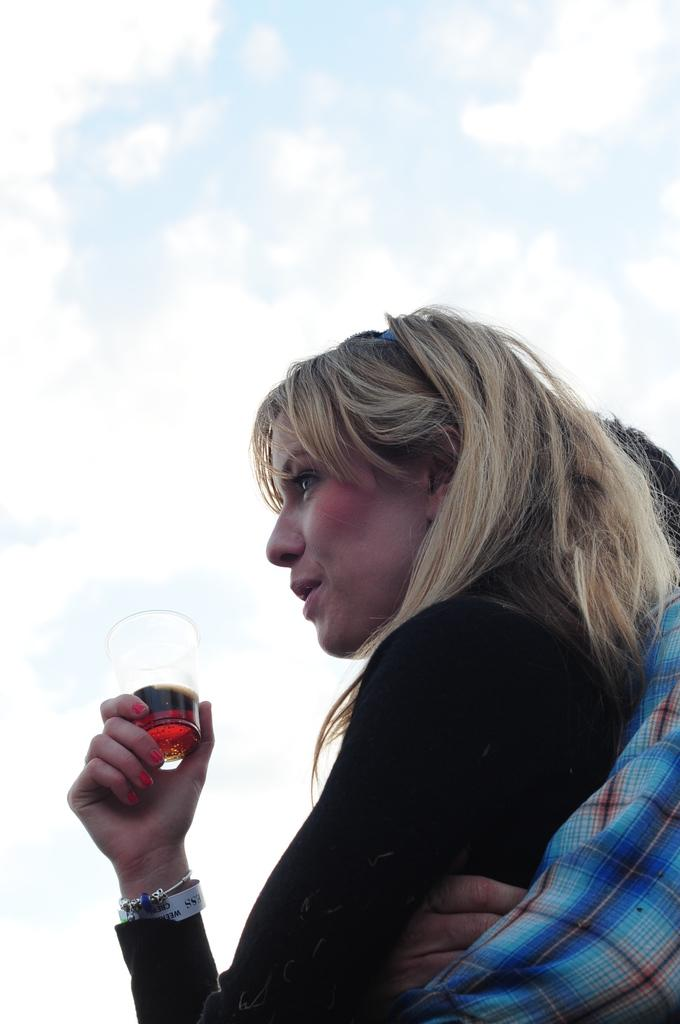Who are the people in the image? There is a man and a woman in the image. What is the woman holding in the image? The woman is holding a glass. What is inside the glass? There is a drink in the glass. What can be seen at the top of the image? The sky is visible at the top of the image. What type of lamp is the spy using to communicate with their team in the image? There is no lamp or spy present in the image; it features a man and a woman with a glass of drink. What time of day is depicted in the image? The provided facts do not specify the time of day, so it cannot be determined from the image. 